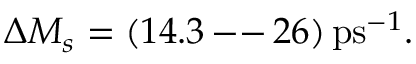Convert formula to latex. <formula><loc_0><loc_0><loc_500><loc_500>\Delta M _ { s } = ( 1 4 . 3 \, - - \, 2 6 ) \, p s ^ { - 1 } .</formula> 